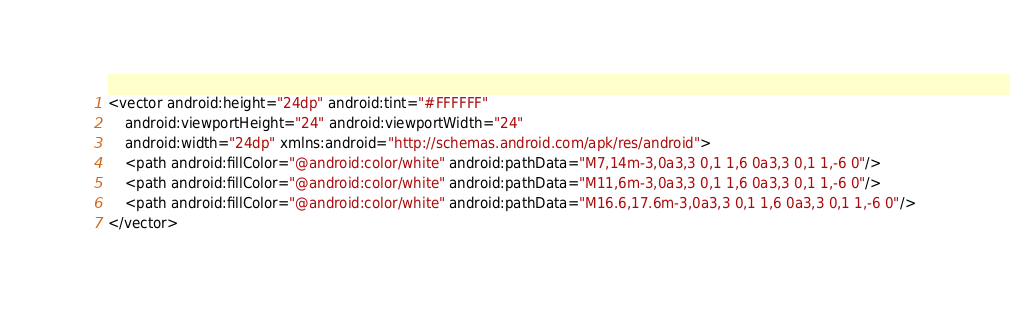<code> <loc_0><loc_0><loc_500><loc_500><_XML_><vector android:height="24dp" android:tint="#FFFFFF"
    android:viewportHeight="24" android:viewportWidth="24"
    android:width="24dp" xmlns:android="http://schemas.android.com/apk/res/android">
    <path android:fillColor="@android:color/white" android:pathData="M7,14m-3,0a3,3 0,1 1,6 0a3,3 0,1 1,-6 0"/>
    <path android:fillColor="@android:color/white" android:pathData="M11,6m-3,0a3,3 0,1 1,6 0a3,3 0,1 1,-6 0"/>
    <path android:fillColor="@android:color/white" android:pathData="M16.6,17.6m-3,0a3,3 0,1 1,6 0a3,3 0,1 1,-6 0"/>
</vector>
</code> 